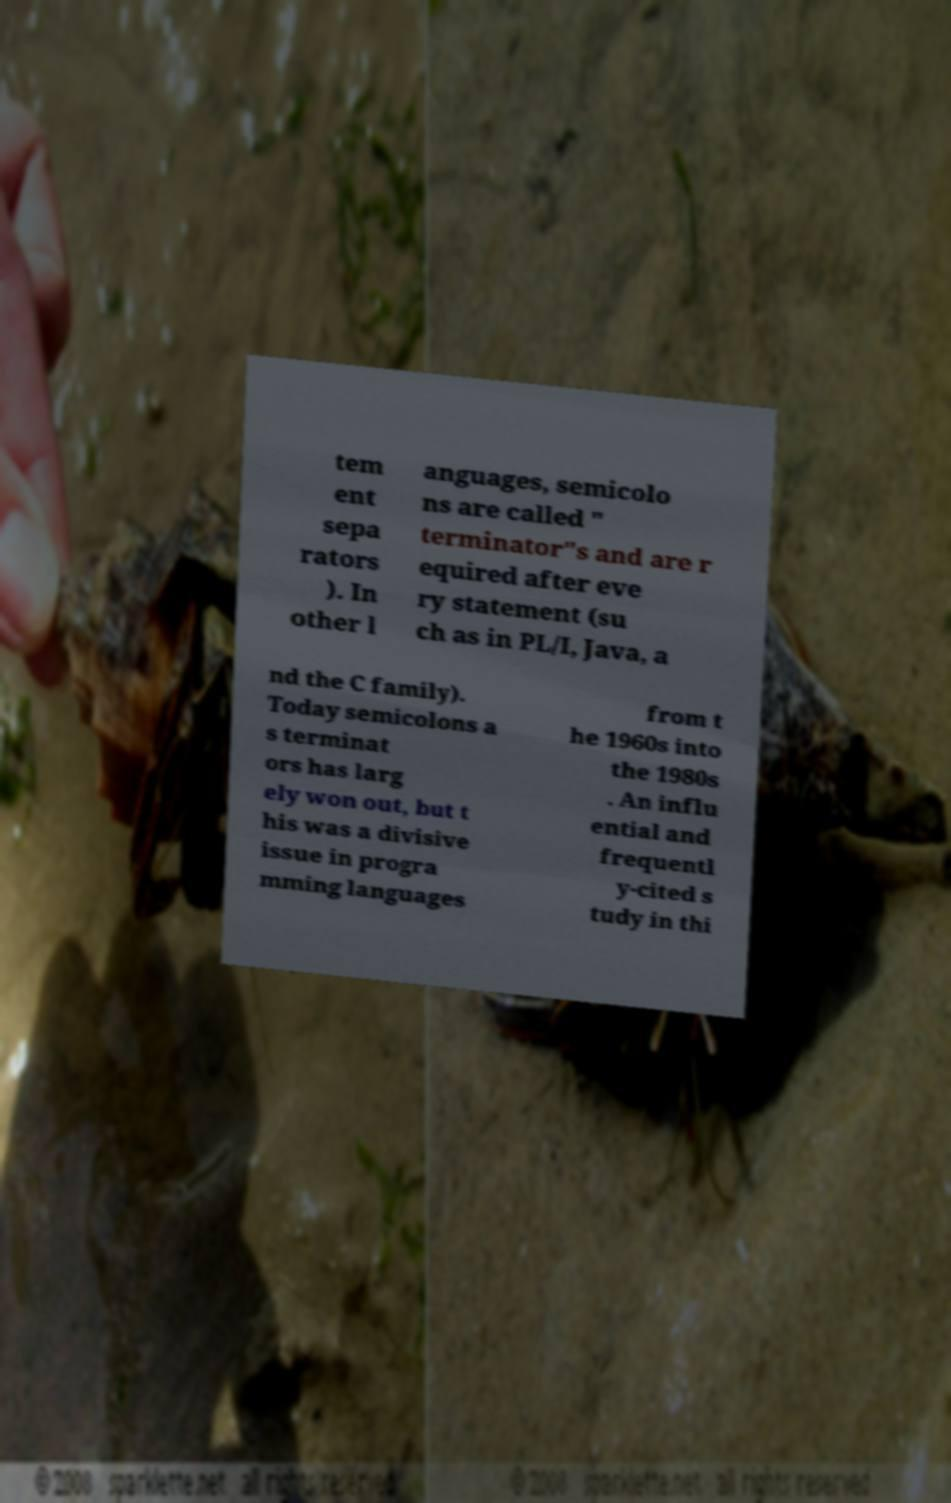There's text embedded in this image that I need extracted. Can you transcribe it verbatim? tem ent sepa rators ). In other l anguages, semicolo ns are called " terminator"s and are r equired after eve ry statement (su ch as in PL/I, Java, a nd the C family). Today semicolons a s terminat ors has larg ely won out, but t his was a divisive issue in progra mming languages from t he 1960s into the 1980s . An influ ential and frequentl y-cited s tudy in thi 